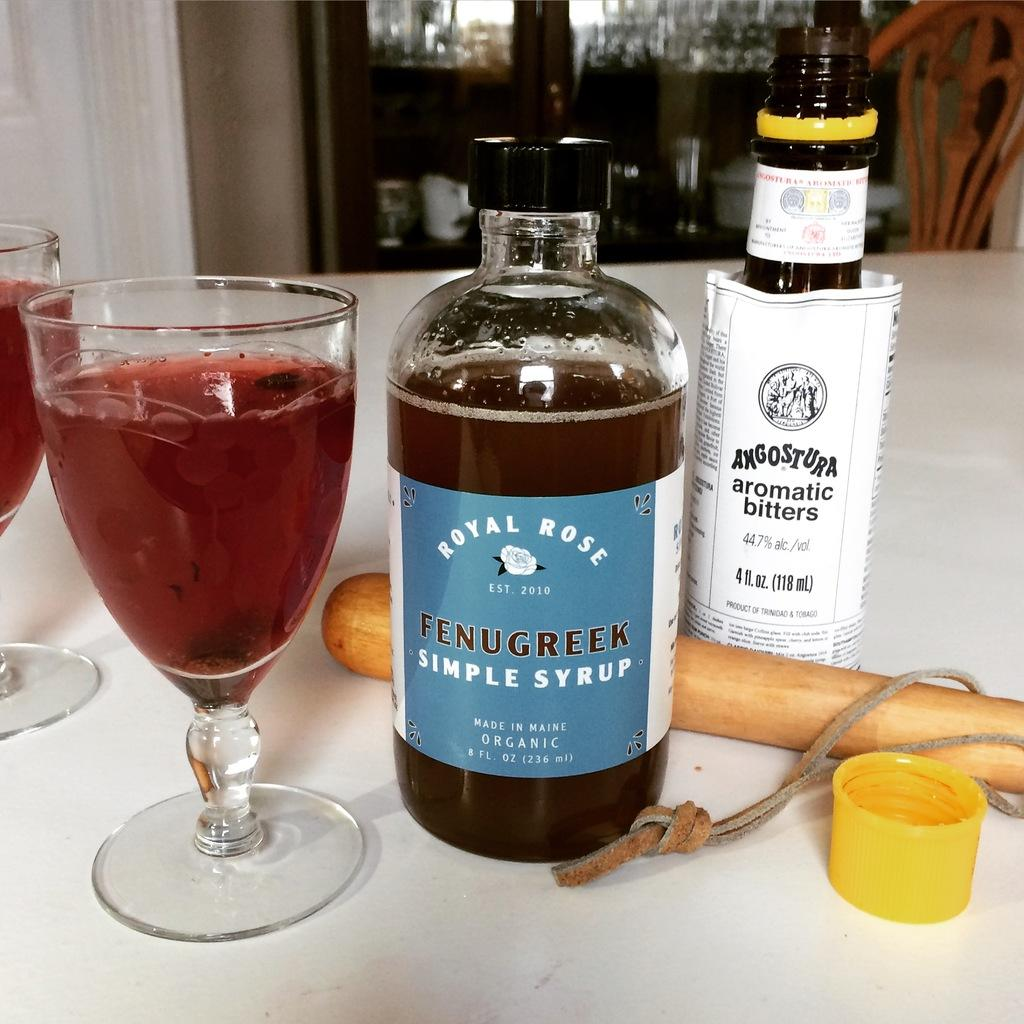<image>
Summarize the visual content of the image. A drink in a glass next to a bottle of simple syrup and aromatic bitters. 